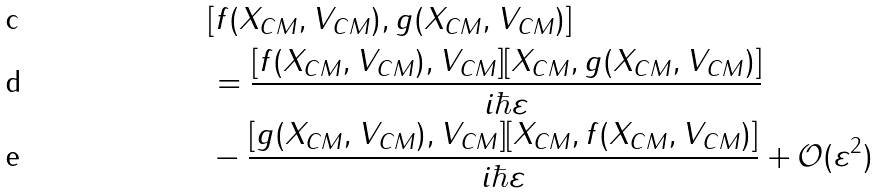<formula> <loc_0><loc_0><loc_500><loc_500>& [ f ( X _ { C M } , V _ { C M } ) , g ( X _ { C M } , V _ { C M } ) ] \\ & = \frac { [ f ( X _ { C M } , V _ { C M } ) , V _ { C M } ] [ X _ { C M } , g ( X _ { C M } , V _ { C M } ) ] } { i \hbar { \varepsilon } } \\ & - \frac { [ g ( X _ { C M } , V _ { C M } ) , V _ { C M } ] [ X _ { C M } , f ( X _ { C M } , V _ { C M } ) ] } { i \hbar { \varepsilon } } + \mathcal { O } ( \varepsilon ^ { 2 } )</formula> 